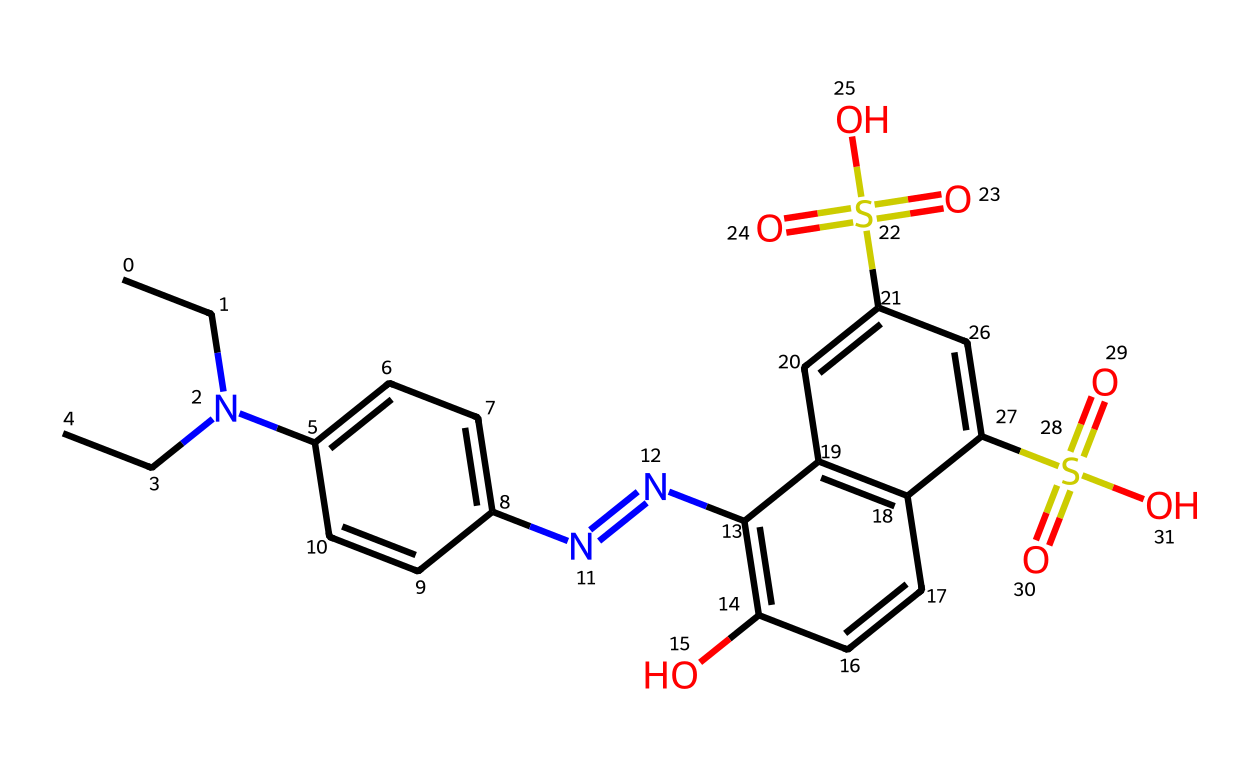How many nitrogen atoms are present in the structure? Counting the nitrogen (N) atoms in the SMILES representation reveals there are two nitrogen atoms.
Answer: two What is the highest oxidation state evident from the structure? The presence of sulfur atoms attached to oxygen in sulfonic acid groups indicates a maximum oxidation state of +6 for sulfur.
Answer: +6 How many carbon atoms are there in this chemical? By analyzing the structure, there are a total of 15 carbon (C) atoms present.
Answer: 15 What functional groups can be identified in this chemical? The structure shows sulfonic acid groups (-SO3H), an alcohol group (-OH), and azo group (-N=N-), indicating multiple functional groups.
Answer: sulfonic acid, alcohol, azo Which part of the structure contributes to its color? The azo group (-N=N-) is typically responsible for imparting color in dyes and colorants, as it allows for vibrant coloration.
Answer: azo group 